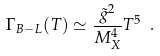<formula> <loc_0><loc_0><loc_500><loc_500>\Gamma _ { B - L } ( T ) \simeq \frac { { \tilde { g } } ^ { 2 } } { M _ { X } ^ { 4 } } T ^ { 5 } \ .</formula> 